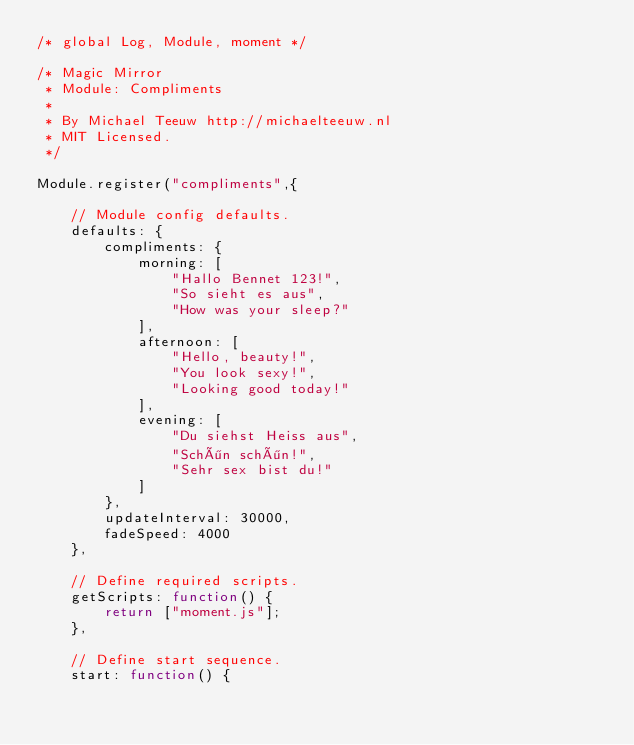Convert code to text. <code><loc_0><loc_0><loc_500><loc_500><_JavaScript_>/* global Log, Module, moment */

/* Magic Mirror
 * Module: Compliments
 *
 * By Michael Teeuw http://michaelteeuw.nl
 * MIT Licensed.
 */

Module.register("compliments",{

	// Module config defaults.
	defaults: {
		compliments: {
			morning: [
				"Hallo Bennet 123!",
				"So sieht es aus",
				"How was your sleep?"
			],
			afternoon: [
				"Hello, beauty!",
				"You look sexy!",
				"Looking good today!"
			],
			evening: [
				"Du siehst Heiss aus",
				"Schön schön!",
				"Sehr sex bist du!"
			]
		},
		updateInterval: 30000,
		fadeSpeed: 4000
	},

	// Define required scripts.
	getScripts: function() {
		return ["moment.js"];
	},

	// Define start sequence.
	start: function() {</code> 